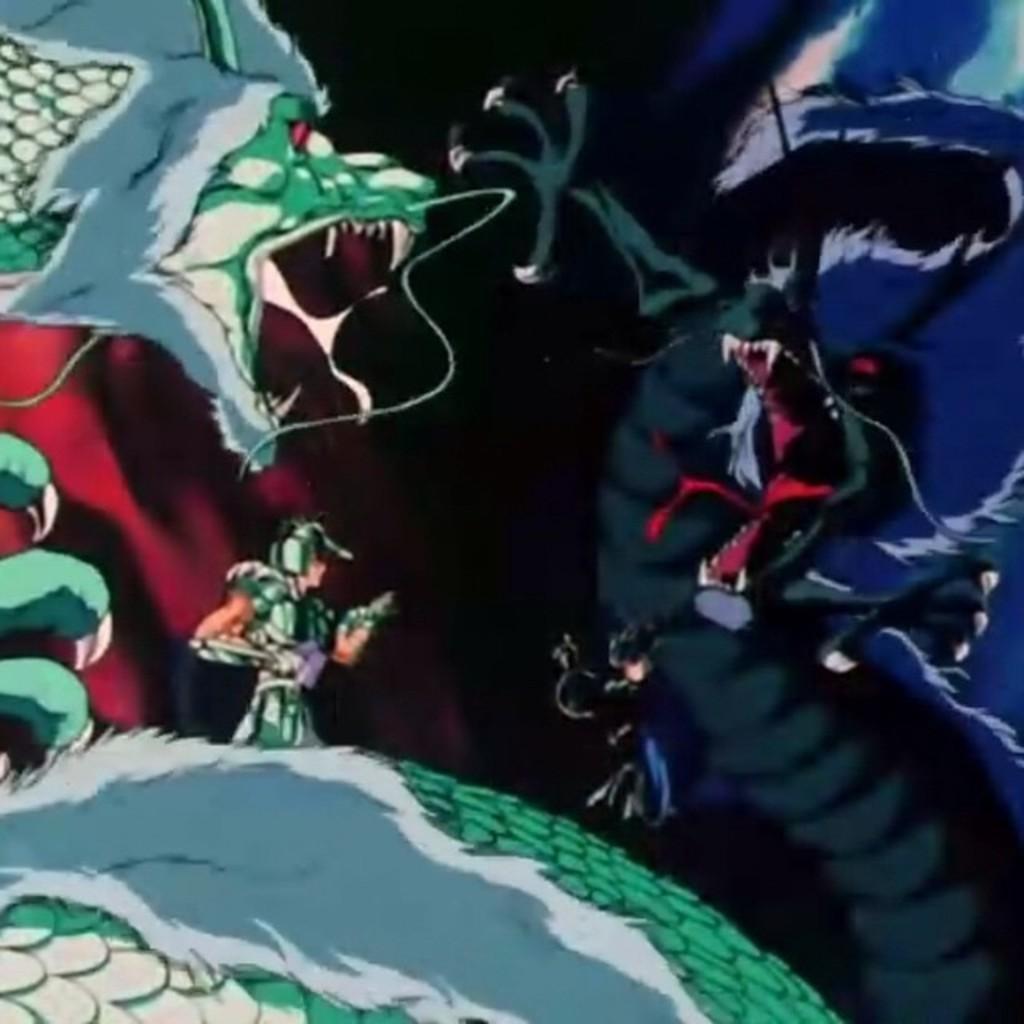Can you describe this image briefly? This is an animated picture, I can see dragons and a person. 